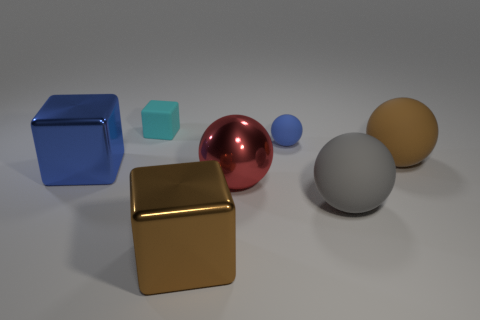Add 2 tiny purple metal cylinders. How many objects exist? 9 Subtract all gray rubber balls. How many balls are left? 3 Subtract all blue balls. How many balls are left? 3 Subtract 1 spheres. How many spheres are left? 3 Subtract 0 gray cylinders. How many objects are left? 7 Subtract all spheres. How many objects are left? 3 Subtract all red cubes. Subtract all brown spheres. How many cubes are left? 3 Subtract all yellow cylinders. How many brown cubes are left? 1 Subtract all big brown things. Subtract all big matte cylinders. How many objects are left? 5 Add 3 gray matte things. How many gray matte things are left? 4 